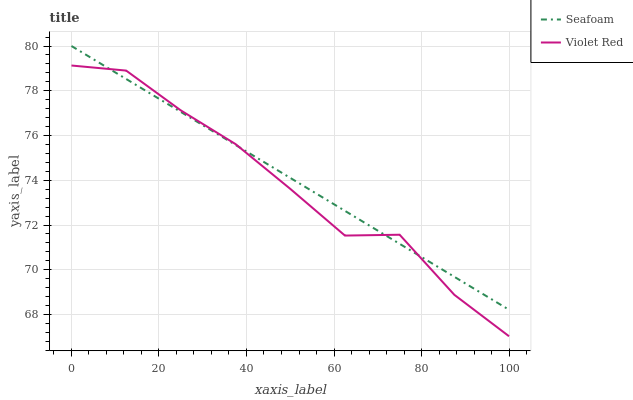Does Violet Red have the minimum area under the curve?
Answer yes or no. Yes. Does Seafoam have the maximum area under the curve?
Answer yes or no. Yes. Does Seafoam have the minimum area under the curve?
Answer yes or no. No. Is Seafoam the smoothest?
Answer yes or no. Yes. Is Violet Red the roughest?
Answer yes or no. Yes. Is Seafoam the roughest?
Answer yes or no. No. Does Violet Red have the lowest value?
Answer yes or no. Yes. Does Seafoam have the lowest value?
Answer yes or no. No. Does Seafoam have the highest value?
Answer yes or no. Yes. Does Seafoam intersect Violet Red?
Answer yes or no. Yes. Is Seafoam less than Violet Red?
Answer yes or no. No. Is Seafoam greater than Violet Red?
Answer yes or no. No. 